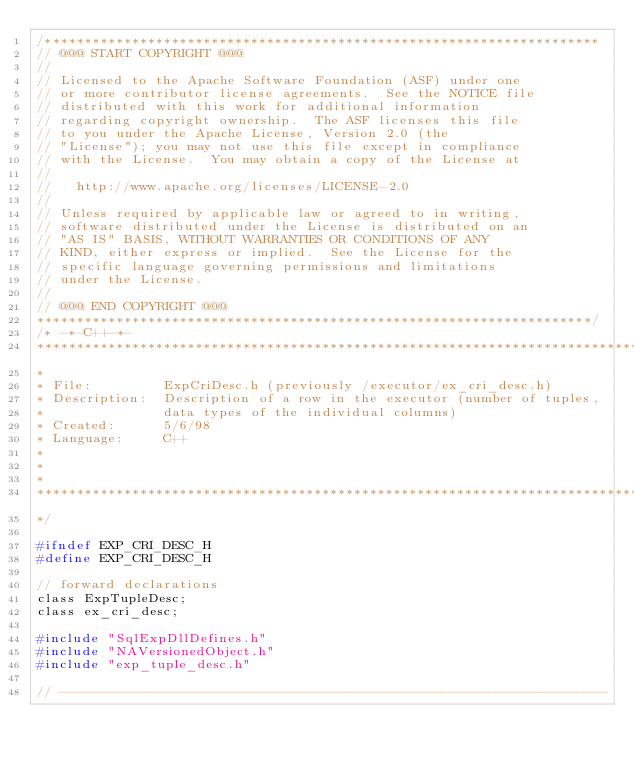Convert code to text. <code><loc_0><loc_0><loc_500><loc_500><_C_>/**********************************************************************
// @@@ START COPYRIGHT @@@
//
// Licensed to the Apache Software Foundation (ASF) under one
// or more contributor license agreements.  See the NOTICE file
// distributed with this work for additional information
// regarding copyright ownership.  The ASF licenses this file
// to you under the Apache License, Version 2.0 (the
// "License"); you may not use this file except in compliance
// with the License.  You may obtain a copy of the License at
//
//   http://www.apache.org/licenses/LICENSE-2.0
//
// Unless required by applicable law or agreed to in writing,
// software distributed under the License is distributed on an
// "AS IS" BASIS, WITHOUT WARRANTIES OR CONDITIONS OF ANY
// KIND, either express or implied.  See the License for the
// specific language governing permissions and limitations
// under the License.
//
// @@@ END COPYRIGHT @@@
**********************************************************************/
/* -*-C++-*-
****************************************************************************
*
* File:         ExpCriDesc.h (previously /executor/ex_cri_desc.h)
* Description:  Description of a row in the executor (number of tuples,
*               data types of the individual columns)
* Created:      5/6/98
* Language:     C++
*
*
*
****************************************************************************
*/

#ifndef EXP_CRI_DESC_H
#define EXP_CRI_DESC_H

// forward declarations
class ExpTupleDesc;
class ex_cri_desc;

#include "SqlExpDllDefines.h"
#include "NAVersionedObject.h"
#include "exp_tuple_desc.h"

// ---------------------------------------------------------------------</code> 